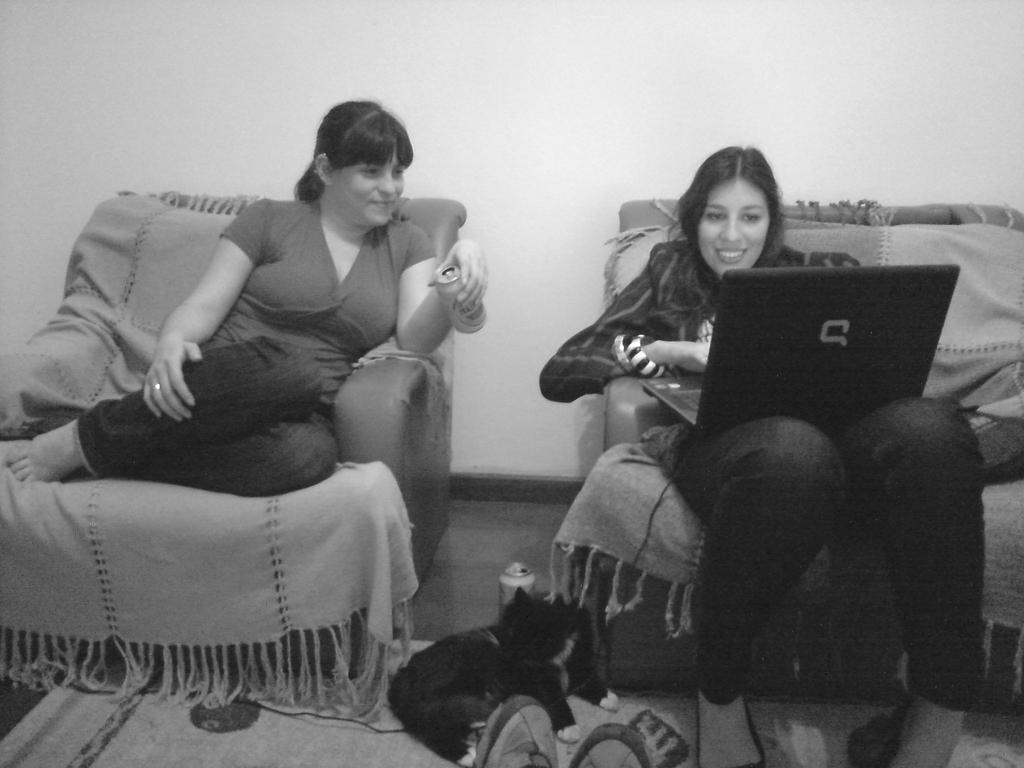Could you give a brief overview of what you see in this image? This picture shows couple of women seated on the chairs and we see a woman holding a laptop and we see a black cat and a can and we see carpet on the floor and we see human legs with shoes. 